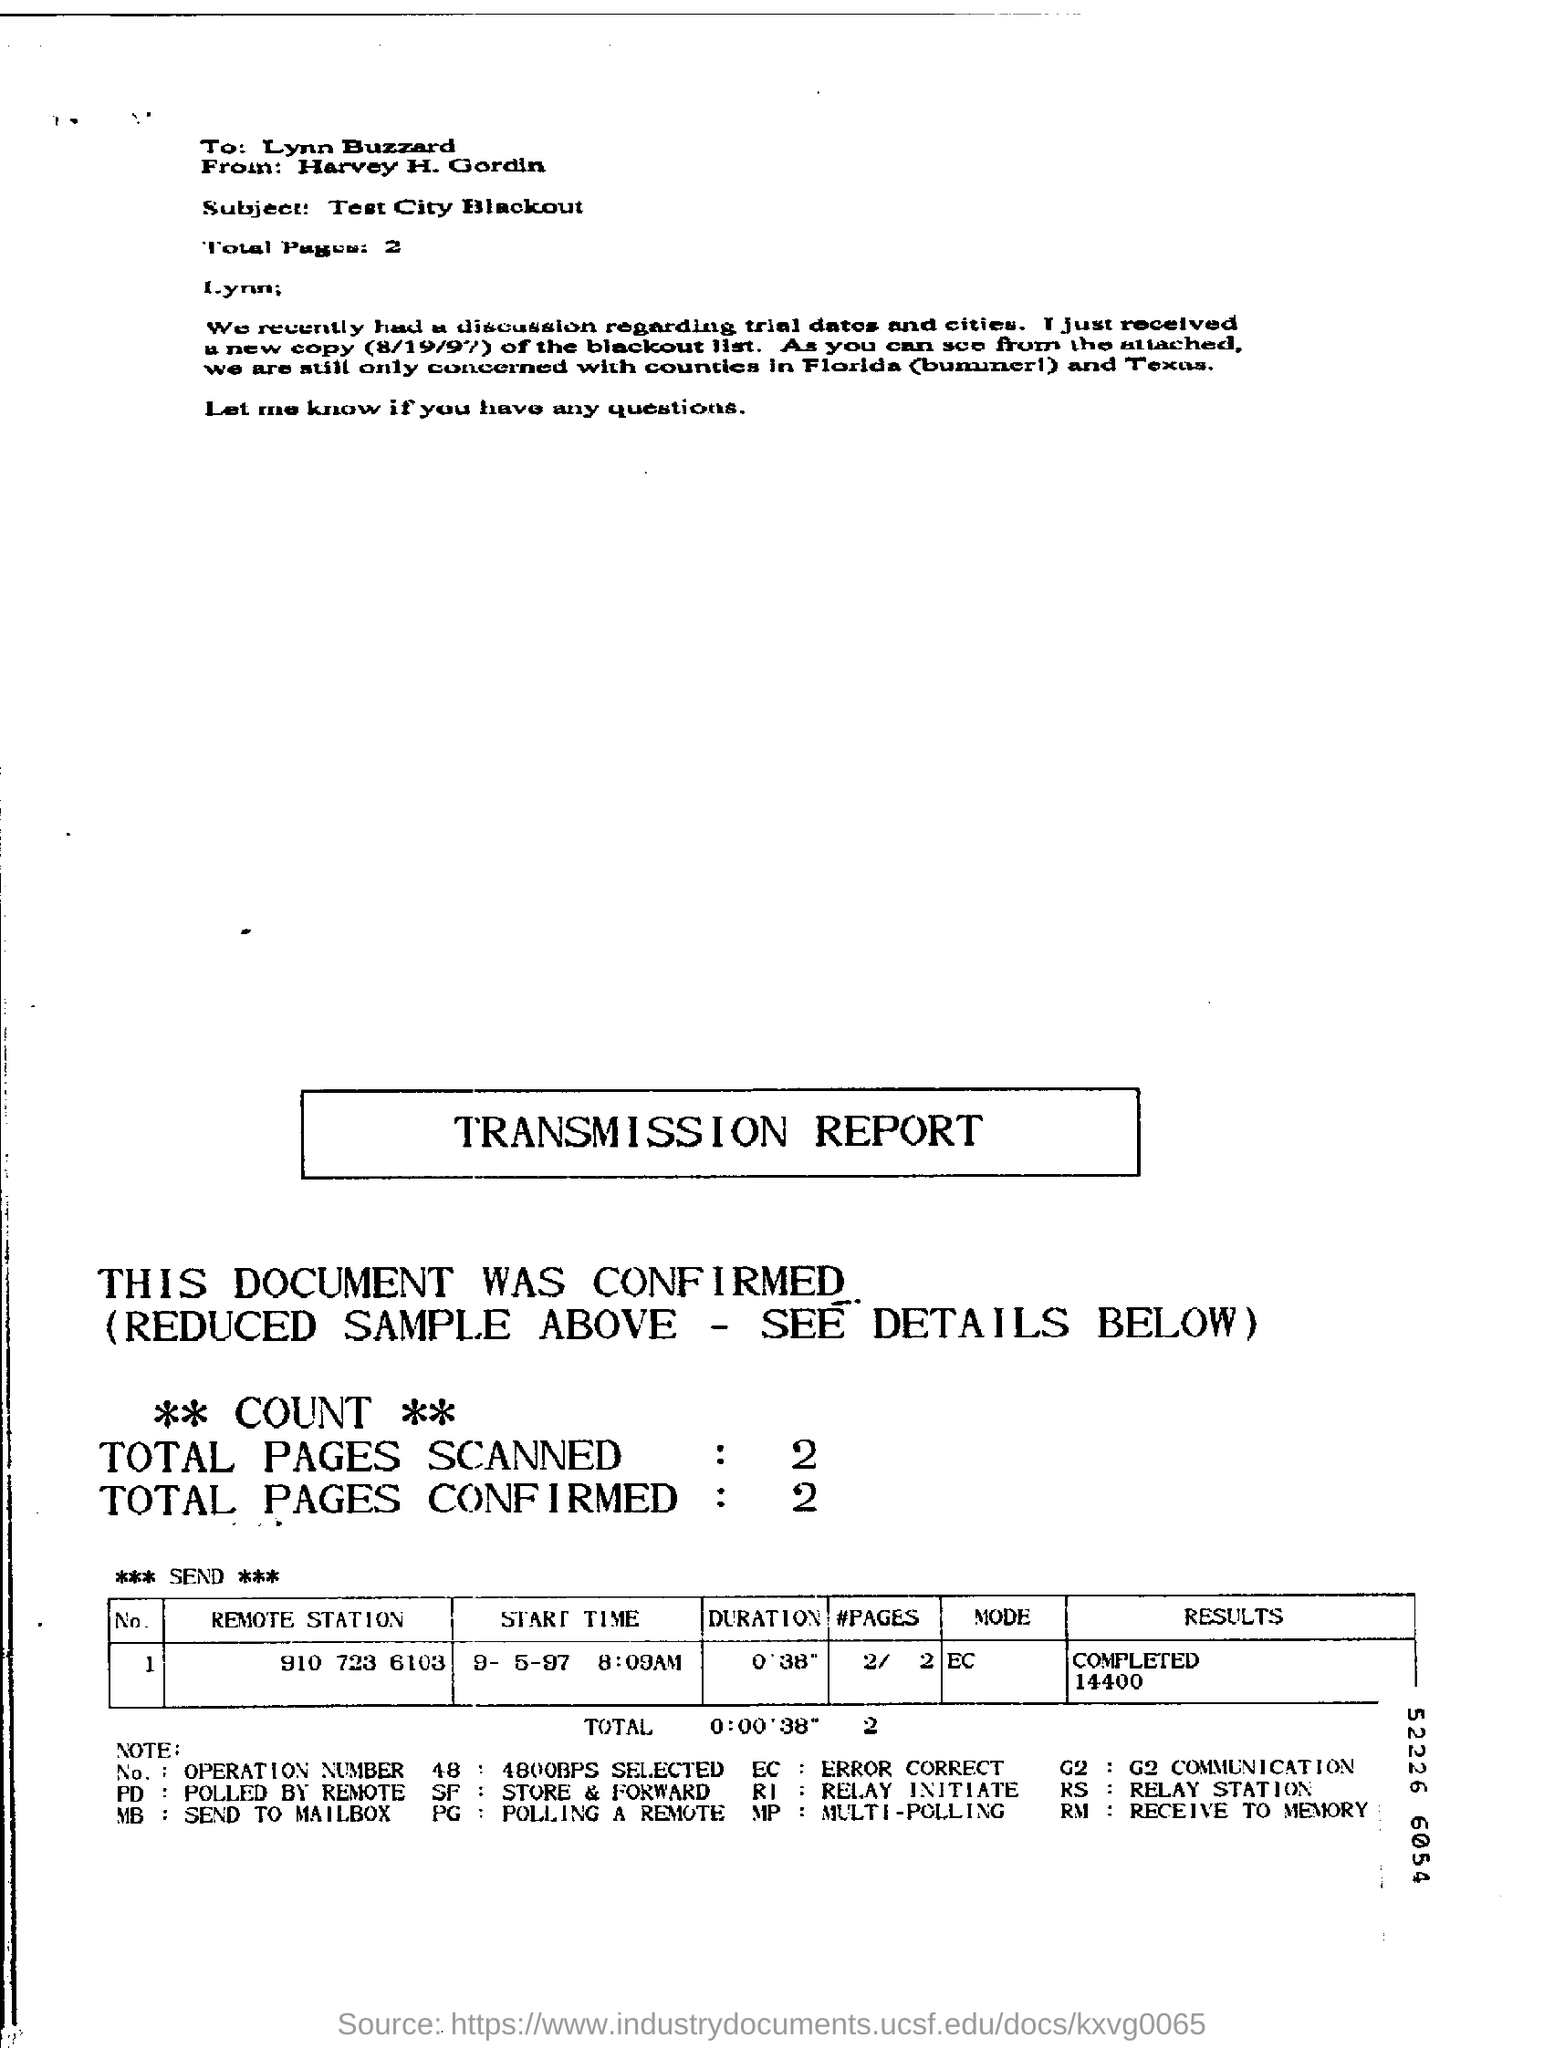Highlight a few significant elements in this photo. The subject of the letter is "What is the subject of the letter? Test City Blackout.. The letter is addressed to Lynn. The letter was sent by Harvey H. Gordin. 